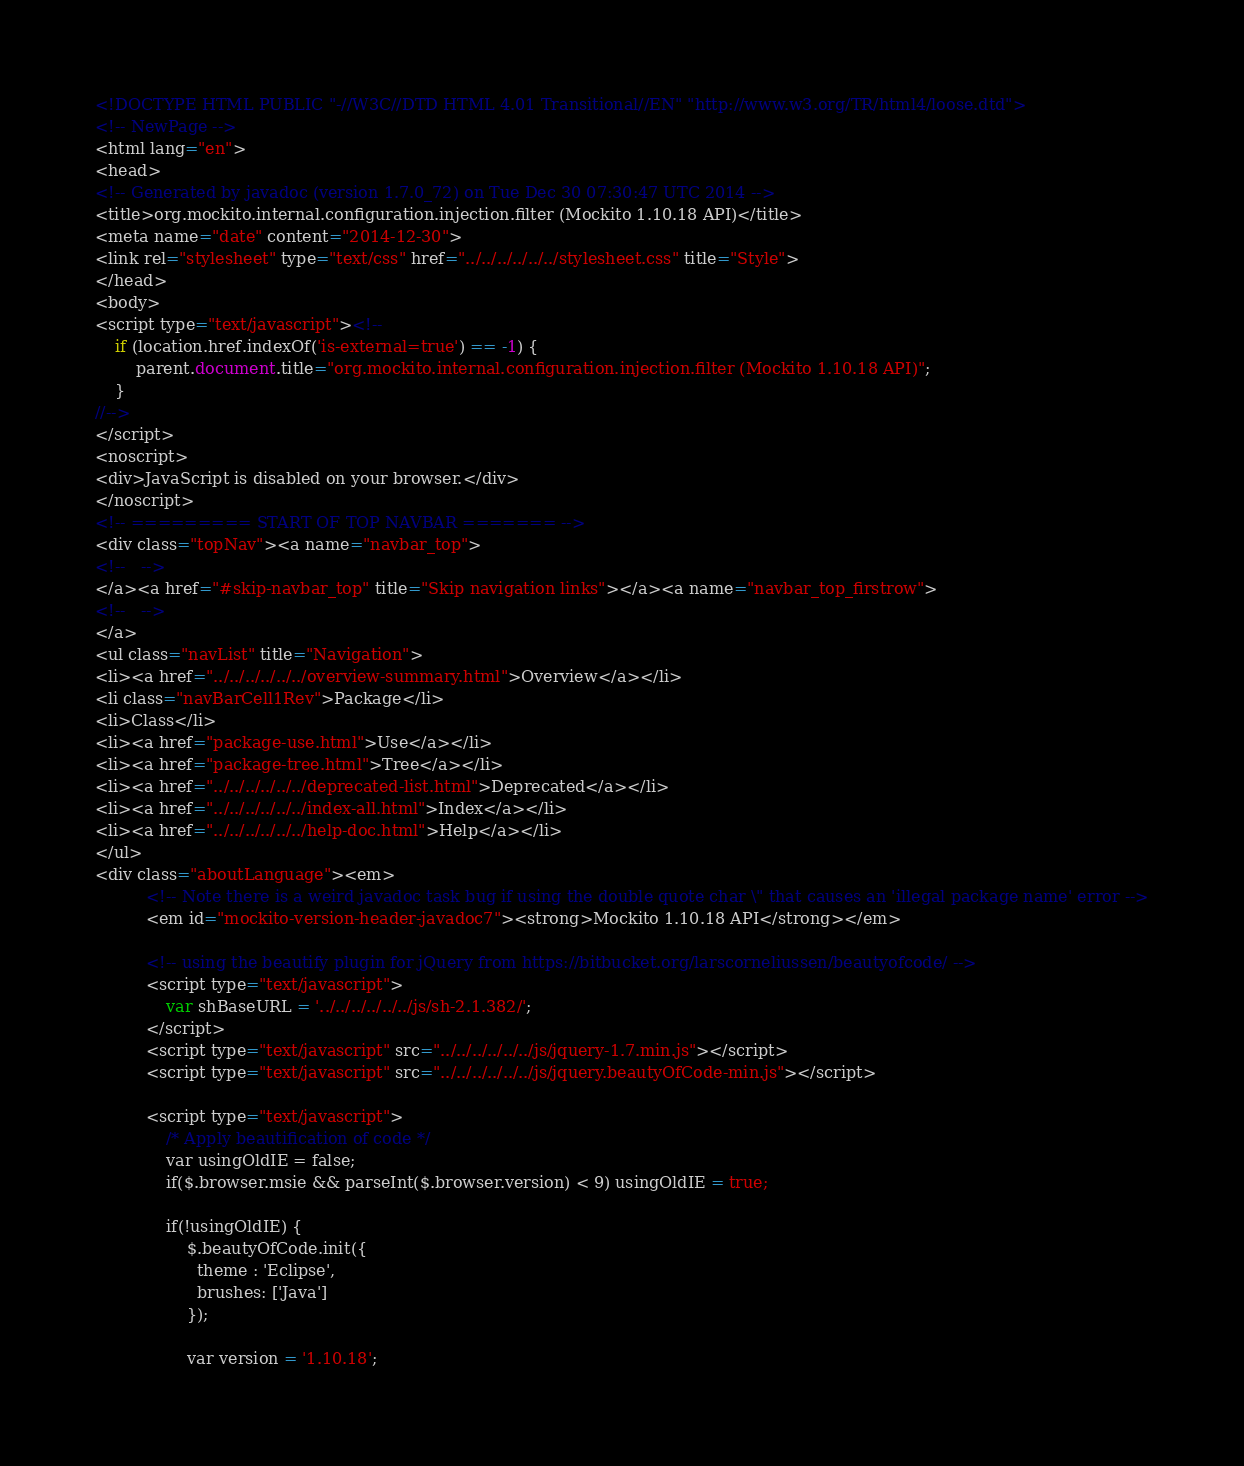<code> <loc_0><loc_0><loc_500><loc_500><_HTML_><!DOCTYPE HTML PUBLIC "-//W3C//DTD HTML 4.01 Transitional//EN" "http://www.w3.org/TR/html4/loose.dtd">
<!-- NewPage -->
<html lang="en">
<head>
<!-- Generated by javadoc (version 1.7.0_72) on Tue Dec 30 07:30:47 UTC 2014 -->
<title>org.mockito.internal.configuration.injection.filter (Mockito 1.10.18 API)</title>
<meta name="date" content="2014-12-30">
<link rel="stylesheet" type="text/css" href="../../../../../../stylesheet.css" title="Style">
</head>
<body>
<script type="text/javascript"><!--
    if (location.href.indexOf('is-external=true') == -1) {
        parent.document.title="org.mockito.internal.configuration.injection.filter (Mockito 1.10.18 API)";
    }
//-->
</script>
<noscript>
<div>JavaScript is disabled on your browser.</div>
</noscript>
<!-- ========= START OF TOP NAVBAR ======= -->
<div class="topNav"><a name="navbar_top">
<!--   -->
</a><a href="#skip-navbar_top" title="Skip navigation links"></a><a name="navbar_top_firstrow">
<!--   -->
</a>
<ul class="navList" title="Navigation">
<li><a href="../../../../../../overview-summary.html">Overview</a></li>
<li class="navBarCell1Rev">Package</li>
<li>Class</li>
<li><a href="package-use.html">Use</a></li>
<li><a href="package-tree.html">Tree</a></li>
<li><a href="../../../../../../deprecated-list.html">Deprecated</a></li>
<li><a href="../../../../../../index-all.html">Index</a></li>
<li><a href="../../../../../../help-doc.html">Help</a></li>
</ul>
<div class="aboutLanguage"><em>
          <!-- Note there is a weird javadoc task bug if using the double quote char \" that causes an 'illegal package name' error -->
          <em id="mockito-version-header-javadoc7"><strong>Mockito 1.10.18 API</strong></em>

          <!-- using the beautify plugin for jQuery from https://bitbucket.org/larscorneliussen/beautyofcode/ -->
          <script type="text/javascript">
              var shBaseURL = '../../../../../../js/sh-2.1.382/';
          </script>
          <script type="text/javascript" src="../../../../../../js/jquery-1.7.min.js"></script>
          <script type="text/javascript" src="../../../../../../js/jquery.beautyOfCode-min.js"></script>

          <script type="text/javascript">
              /* Apply beautification of code */
              var usingOldIE = false;
              if($.browser.msie && parseInt($.browser.version) < 9) usingOldIE = true;

              if(!usingOldIE) {
                  $.beautyOfCode.init({
                    theme : 'Eclipse',
                    brushes: ['Java']
                  });

                  var version = '1.10.18';
</code> 